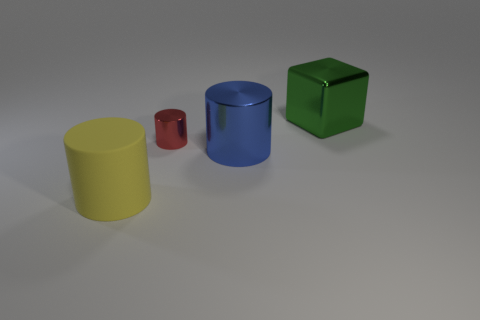Subtract all big matte cylinders. How many cylinders are left? 2 Subtract all yellow cylinders. How many cylinders are left? 2 Add 1 tiny shiny cylinders. How many objects exist? 5 Subtract 1 cylinders. How many cylinders are left? 2 Subtract all purple cubes. How many red cylinders are left? 1 Add 2 small cylinders. How many small cylinders are left? 3 Add 2 purple metal spheres. How many purple metal spheres exist? 2 Subtract 0 brown cylinders. How many objects are left? 4 Subtract all cylinders. How many objects are left? 1 Subtract all purple cylinders. Subtract all gray spheres. How many cylinders are left? 3 